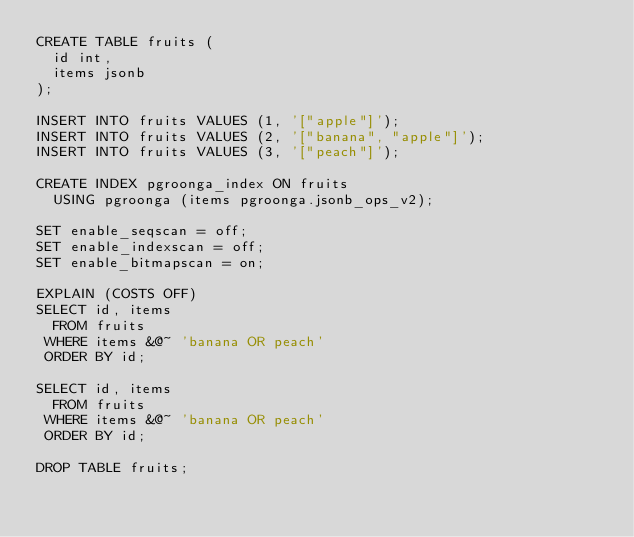Convert code to text. <code><loc_0><loc_0><loc_500><loc_500><_SQL_>CREATE TABLE fruits (
  id int,
  items jsonb
);

INSERT INTO fruits VALUES (1, '["apple"]');
INSERT INTO fruits VALUES (2, '["banana", "apple"]');
INSERT INTO fruits VALUES (3, '["peach"]');

CREATE INDEX pgroonga_index ON fruits
  USING pgroonga (items pgroonga.jsonb_ops_v2);

SET enable_seqscan = off;
SET enable_indexscan = off;
SET enable_bitmapscan = on;

EXPLAIN (COSTS OFF)
SELECT id, items
  FROM fruits
 WHERE items &@~ 'banana OR peach'
 ORDER BY id;

SELECT id, items
  FROM fruits
 WHERE items &@~ 'banana OR peach'
 ORDER BY id;

DROP TABLE fruits;
</code> 